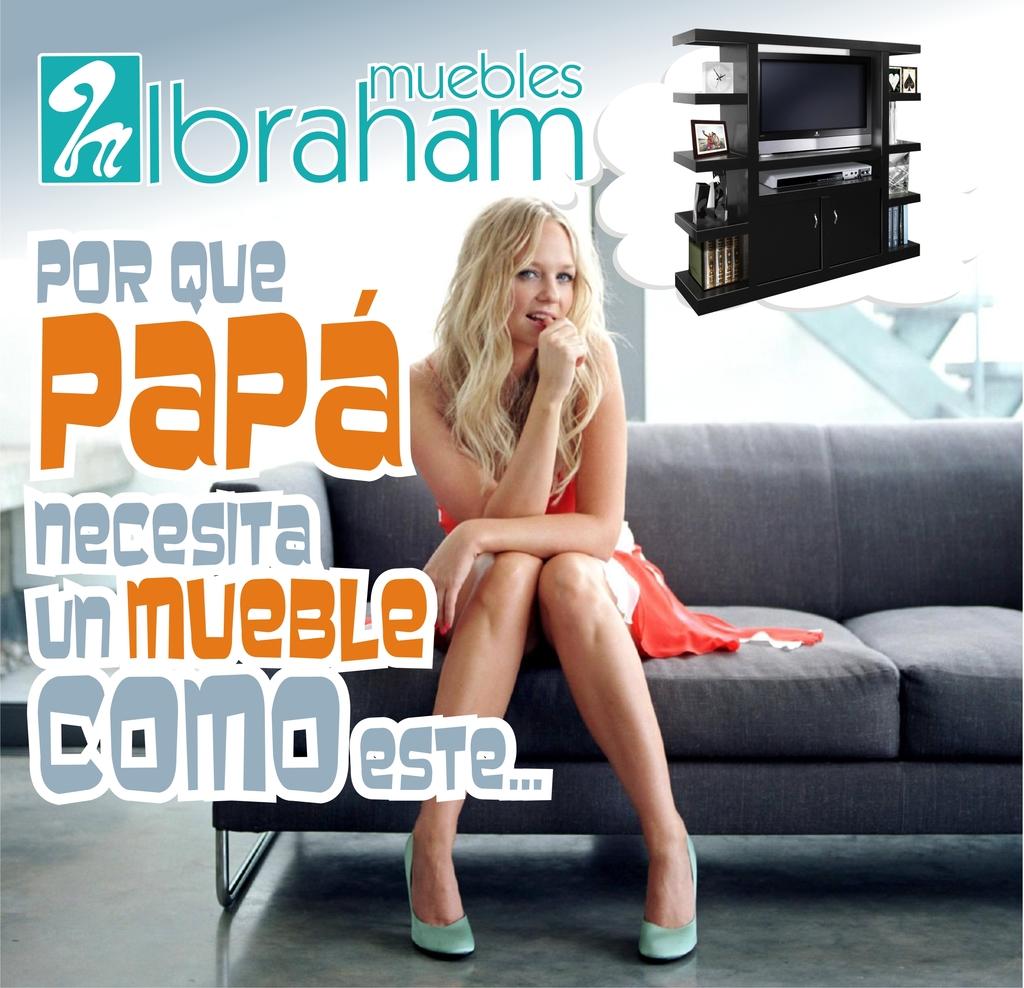What word comes after que?
Offer a terse response. Papa. 